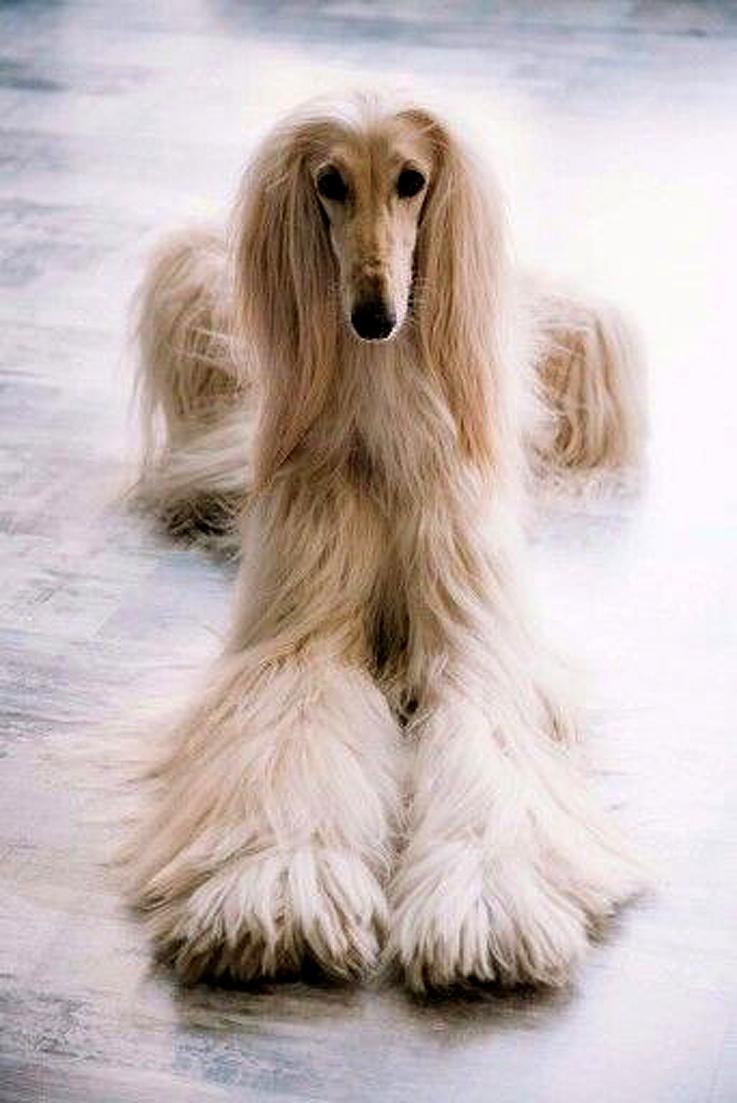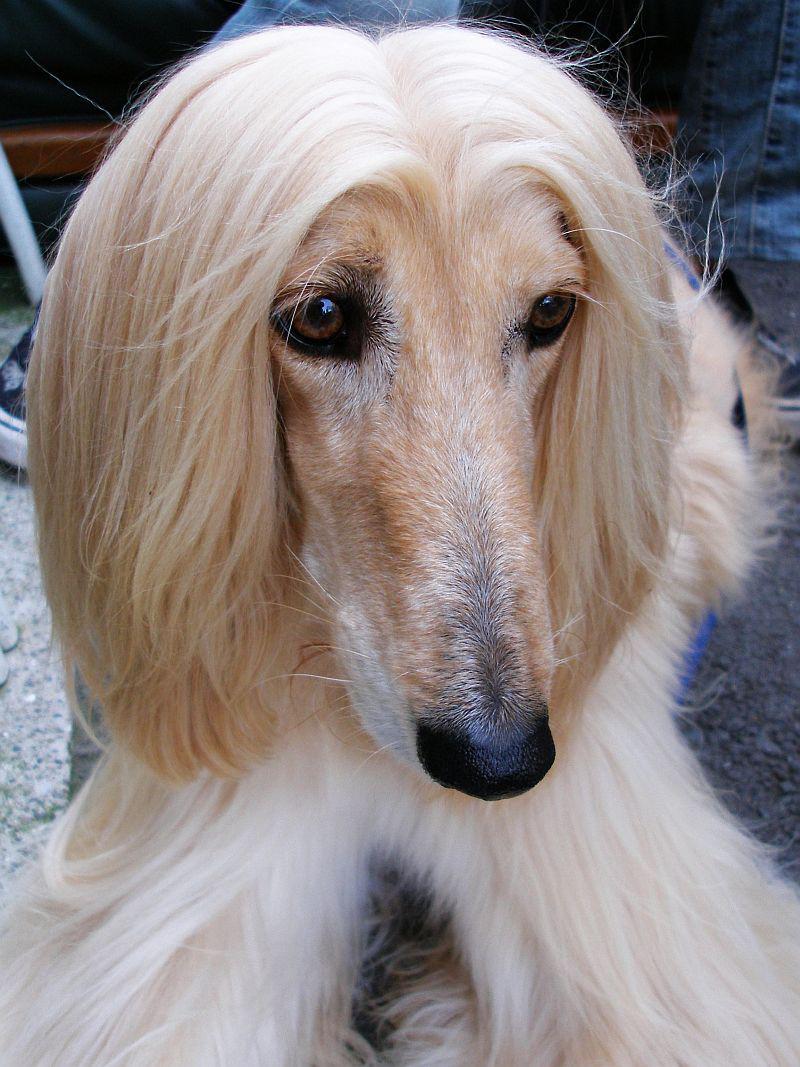The first image is the image on the left, the second image is the image on the right. For the images displayed, is the sentence "One image shows a hound with windswept hair on its head." factually correct? Answer yes or no. No. 